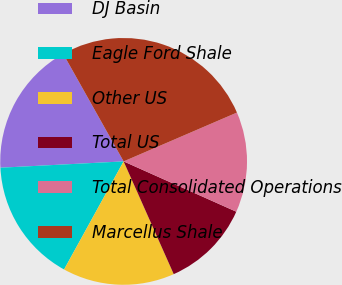Convert chart to OTSL. <chart><loc_0><loc_0><loc_500><loc_500><pie_chart><fcel>DJ Basin<fcel>Eagle Ford Shale<fcel>Other US<fcel>Total US<fcel>Total Consolidated Operations<fcel>Marcellus Shale<nl><fcel>17.67%<fcel>16.17%<fcel>14.67%<fcel>11.66%<fcel>13.16%<fcel>26.67%<nl></chart> 